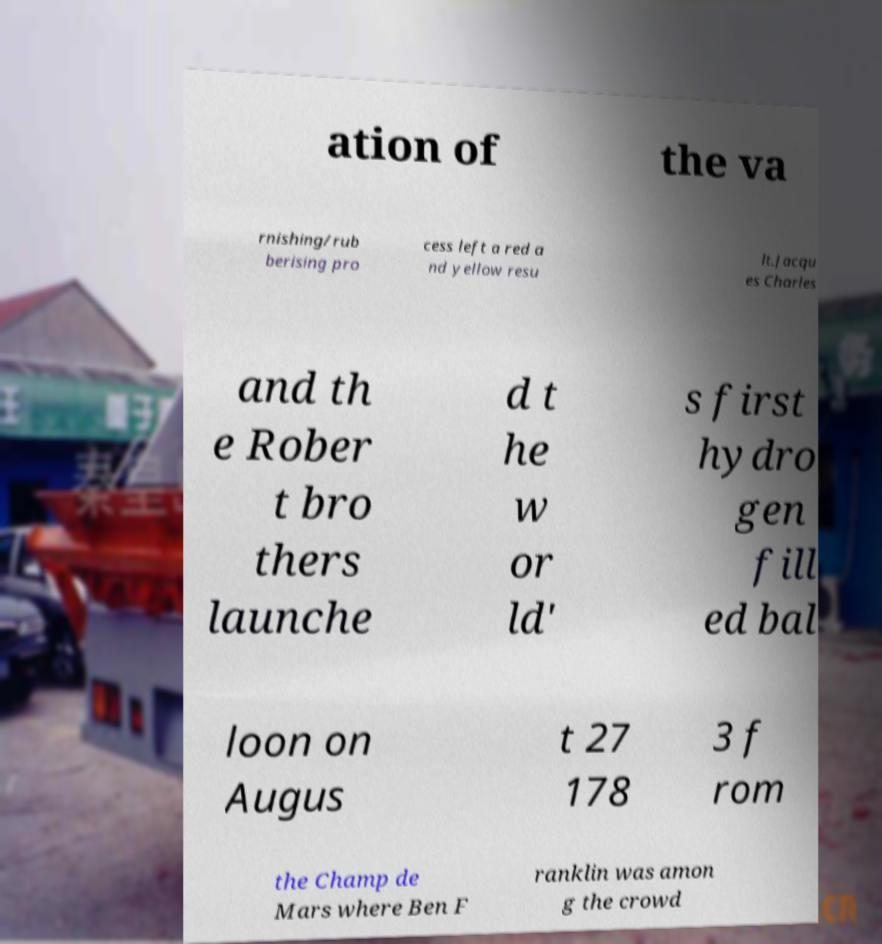Can you accurately transcribe the text from the provided image for me? ation of the va rnishing/rub berising pro cess left a red a nd yellow resu lt.Jacqu es Charles and th e Rober t bro thers launche d t he w or ld' s first hydro gen fill ed bal loon on Augus t 27 178 3 f rom the Champ de Mars where Ben F ranklin was amon g the crowd 